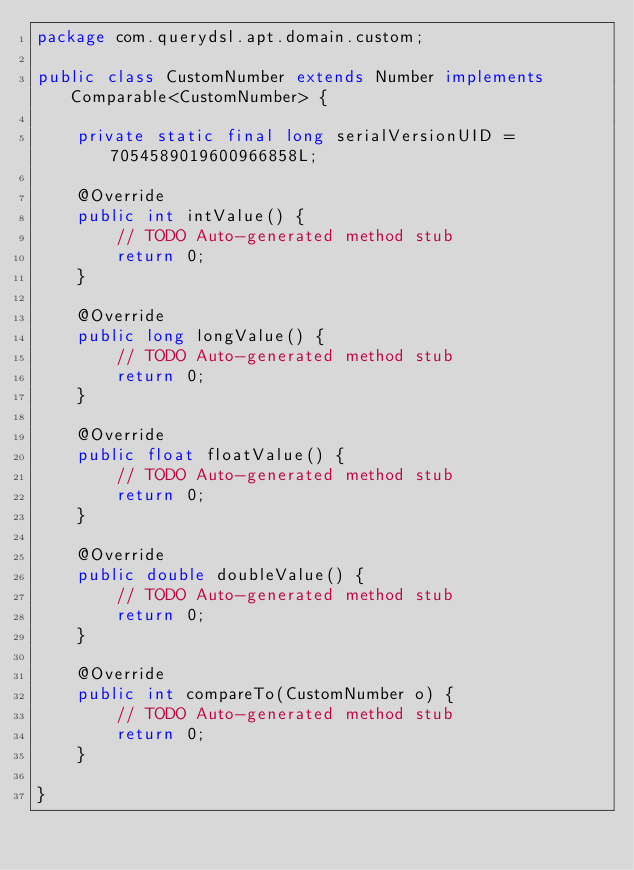<code> <loc_0><loc_0><loc_500><loc_500><_Java_>package com.querydsl.apt.domain.custom;

public class CustomNumber extends Number implements Comparable<CustomNumber> {

    private static final long serialVersionUID = 7054589019600966858L;

    @Override
    public int intValue() {
        // TODO Auto-generated method stub
        return 0;
    }

    @Override
    public long longValue() {
        // TODO Auto-generated method stub
        return 0;
    }

    @Override
    public float floatValue() {
        // TODO Auto-generated method stub
        return 0;
    }

    @Override
    public double doubleValue() {
        // TODO Auto-generated method stub
        return 0;
    }

    @Override
    public int compareTo(CustomNumber o) {
        // TODO Auto-generated method stub
        return 0;
    }

}</code> 